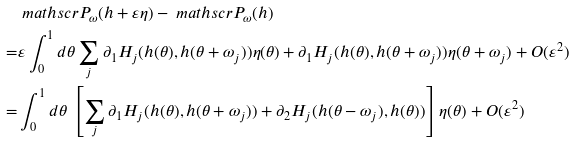Convert formula to latex. <formula><loc_0><loc_0><loc_500><loc_500>& \ m a t h s c r { P } _ { \omega } ( h + \varepsilon \eta ) - \ m a t h s c r { P } _ { \omega } ( h ) \\ = & \varepsilon \int _ { 0 } ^ { 1 } d \theta \sum _ { j } \partial _ { 1 } H _ { j } ( h ( \theta ) , h ( \theta + \omega _ { j } ) ) \eta ( \theta ) + \partial _ { 1 } H _ { j } ( h ( \theta ) , h ( \theta + \omega _ { j } ) ) \eta ( \theta + \omega _ { j } ) + O ( \varepsilon ^ { 2 } ) \\ = & \int _ { 0 } ^ { 1 } d \theta \, \left [ \sum _ { j } \partial _ { 1 } H _ { j } ( h ( \theta ) , h ( \theta + \omega _ { j } ) ) + \partial _ { 2 } H _ { j } ( h ( \theta - \omega _ { j } ) , h ( \theta ) ) \right ] \eta ( \theta ) + O ( \varepsilon ^ { 2 } )</formula> 